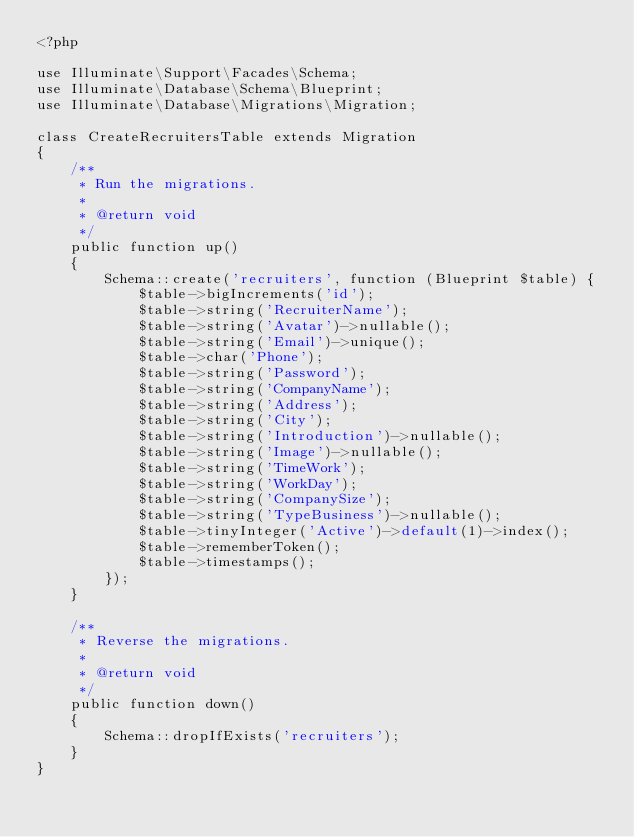Convert code to text. <code><loc_0><loc_0><loc_500><loc_500><_PHP_><?php

use Illuminate\Support\Facades\Schema;
use Illuminate\Database\Schema\Blueprint;
use Illuminate\Database\Migrations\Migration;

class CreateRecruitersTable extends Migration
{
    /**
     * Run the migrations.
     *
     * @return void
     */
    public function up()
    {
        Schema::create('recruiters', function (Blueprint $table) {
            $table->bigIncrements('id');
            $table->string('RecruiterName');
            $table->string('Avatar')->nullable();
            $table->string('Email')->unique();
            $table->char('Phone');
            $table->string('Password');
            $table->string('CompanyName');
            $table->string('Address');
            $table->string('City');
            $table->string('Introduction')->nullable();
            $table->string('Image')->nullable();
            $table->string('TimeWork');
            $table->string('WorkDay');
            $table->string('CompanySize');
            $table->string('TypeBusiness')->nullable();
            $table->tinyInteger('Active')->default(1)->index();
            $table->rememberToken();
            $table->timestamps();
        });
    }

    /**
     * Reverse the migrations.
     *
     * @return void
     */
    public function down()
    {
        Schema::dropIfExists('recruiters');
    }
}
</code> 